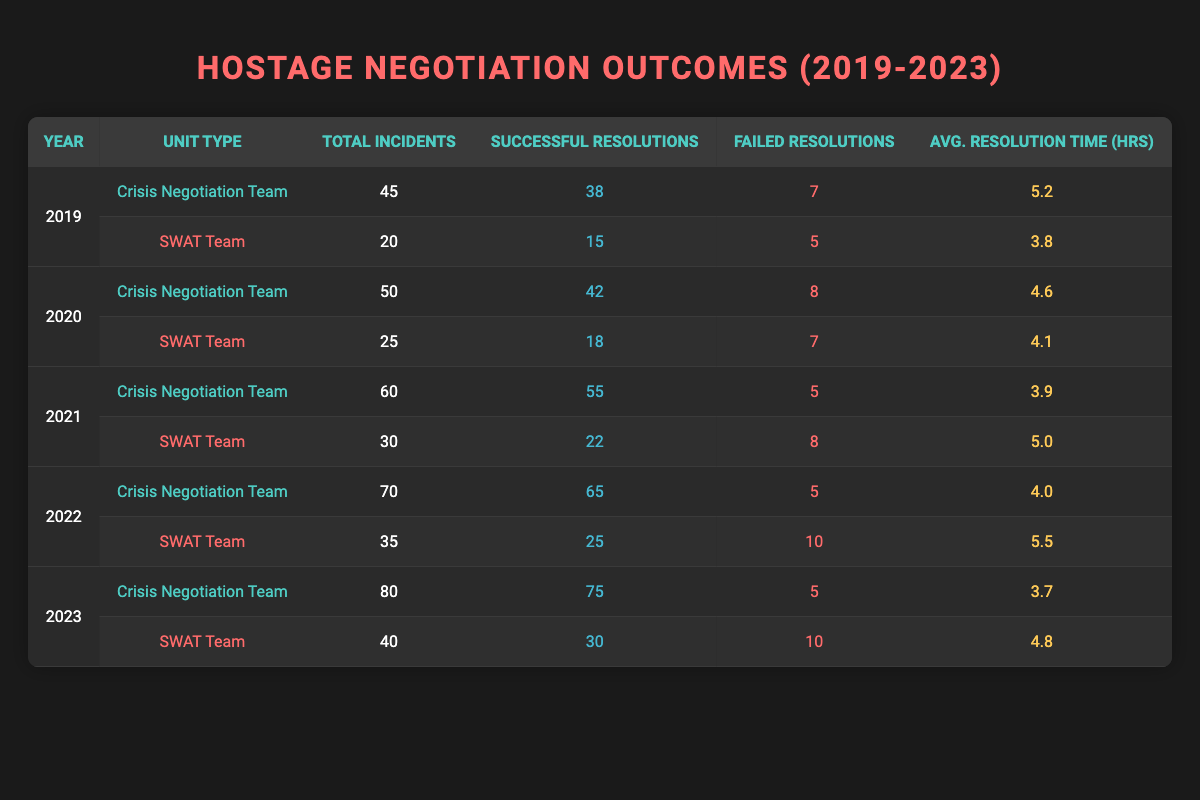What was the total number of incidents handled by the Crisis Negotiation Team in 2021? In 2021, the Crisis Negotiation Team handled a total of 60 incidents as shown in the table.
Answer: 60 How many successful resolutions did the SWAT Team achieve in 2022? The SWAT Team achieved 25 successful resolutions in 2022 according to the table data.
Answer: 25 What is the average resolution time for the Crisis Negotiation Team in 2023? The average resolution time for the Crisis Negotiation Team in 2023 is 3.7 hours as indicated in the table.
Answer: 3.7 Which unit had a higher successful resolution rate in 2020, and what was that rate? In 2020, the Crisis Negotiation Team had 42 successful resolutions out of 50 incidents, giving a resolution rate of 84%. The SWAT Team had 18 successful resolutions out of 25 incidents, giving a rate of 72%. Therefore, the Crisis Negotiation Team had a higher rate of 84%.
Answer: Crisis Negotiation Team, 84% What is the total number of failed resolutions for the SWAT Team from 2019 to 2023? The failed resolutions for the SWAT Team are 5 (2019) + 7 (2020) + 8 (2021) + 10 (2022) + 10 (2023) = 40.
Answer: 40 Is it true that the average resolution time for both unit types decreased over the years? Looking at the average resolution times, the Crisis Negotiation Team's times went from 5.2 to 4.6, then to 3.9, 4.0, and finally 3.7, showing a decrease. The SWAT Team's times were 3.8, 4.1, 5.0, 5.5, and 4.8, which do not show a consistent decrease. Therefore, it is false that both types consistently decreased.
Answer: False What year had the highest number of total incidents for the Crisis Negotiation Team, and how many were there? The Crisis Negotiation Team had the highest total incidents in 2023 with 80 incidents based on the data in the table.
Answer: 2023, 80 If we compare 2019 to 2023, how much did the successful resolutions for the Crisis Negotiation Team increase? In 2019, the Crisis Negotiation Team had 38 successful resolutions, and by 2023, they had 75. The increase is 75 - 38 = 37 successful resolutions.
Answer: 37 What was the proportion of failed resolutions to total incidents for the SWAT Team in 2021? In 2021, the SWAT Team had 8 failed resolutions out of 30 total incidents, giving a proportion of 8/30 = 0.27 (or 27%).
Answer: 27% Which year recorded the lowest average resolution time for the SWAT Team, and what was that time? The SWAT Team recorded its lowest average resolution time in 2019 with 3.8 hours according to the table data.
Answer: 2019, 3.8 